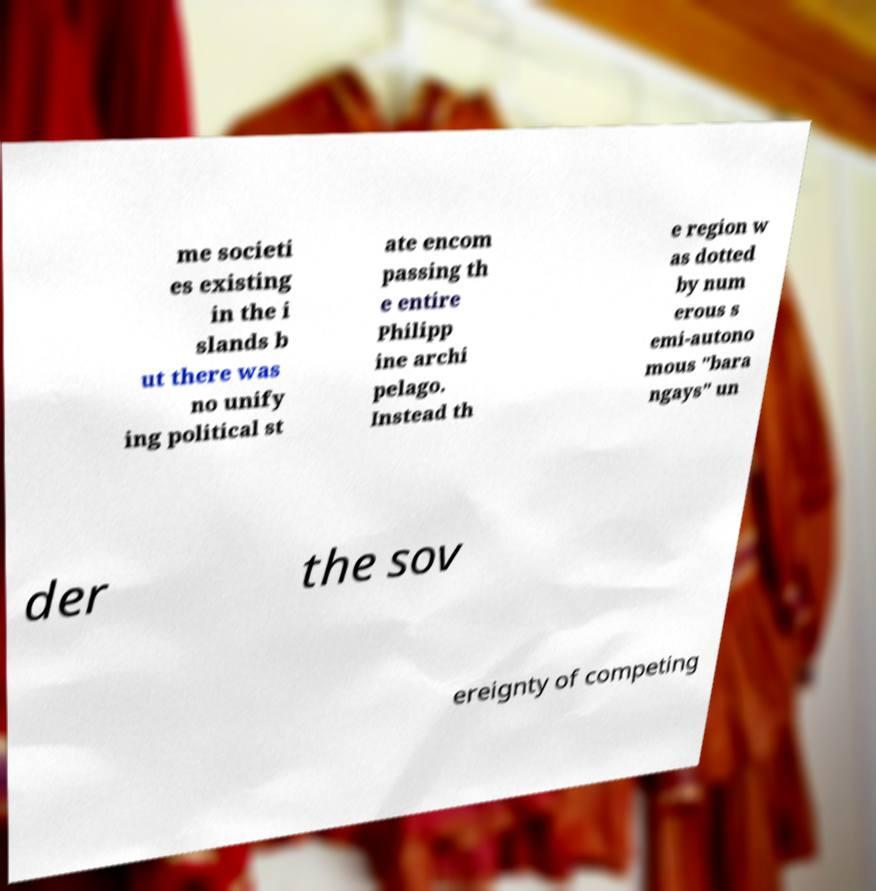There's text embedded in this image that I need extracted. Can you transcribe it verbatim? me societi es existing in the i slands b ut there was no unify ing political st ate encom passing th e entire Philipp ine archi pelago. Instead th e region w as dotted by num erous s emi-autono mous "bara ngays" un der the sov ereignty of competing 